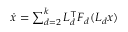<formula> <loc_0><loc_0><loc_500><loc_500>\begin{array} { r } { \dot { x } = \sum _ { d = 2 } ^ { k } L _ { d } ^ { \top } F _ { d } ( L _ { d } x ) } \end{array}</formula> 